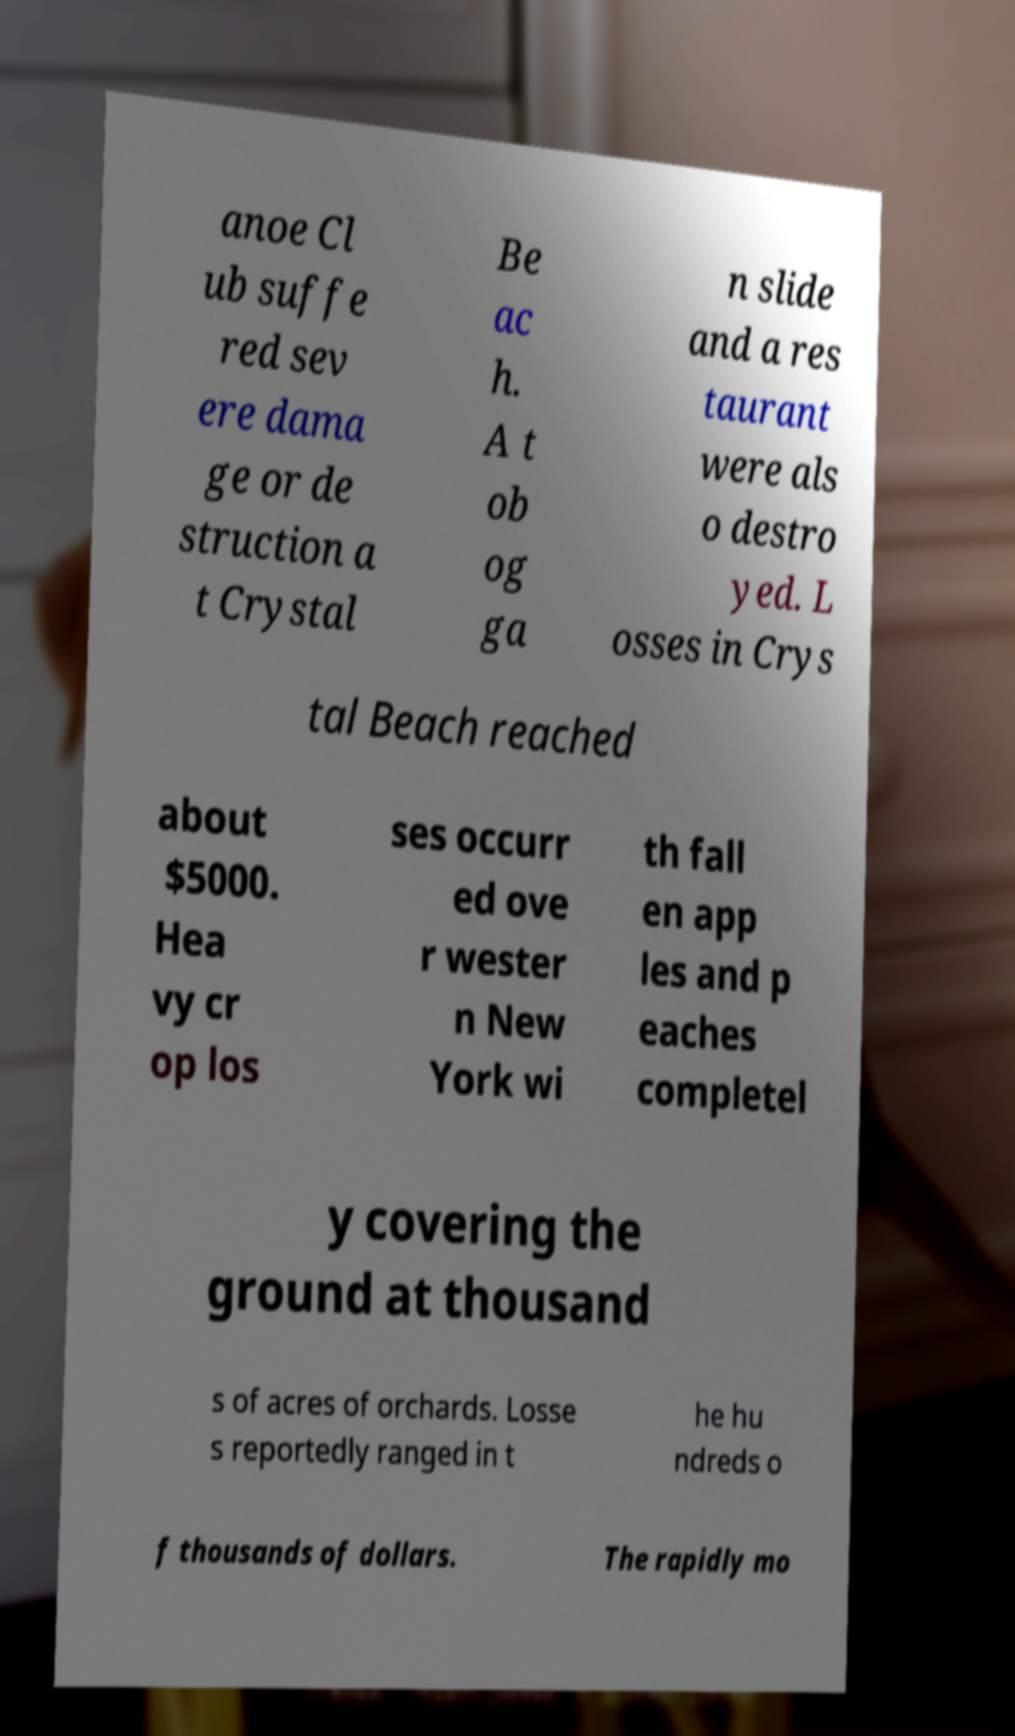Can you accurately transcribe the text from the provided image for me? anoe Cl ub suffe red sev ere dama ge or de struction a t Crystal Be ac h. A t ob og ga n slide and a res taurant were als o destro yed. L osses in Crys tal Beach reached about $5000. Hea vy cr op los ses occurr ed ove r wester n New York wi th fall en app les and p eaches completel y covering the ground at thousand s of acres of orchards. Losse s reportedly ranged in t he hu ndreds o f thousands of dollars. The rapidly mo 